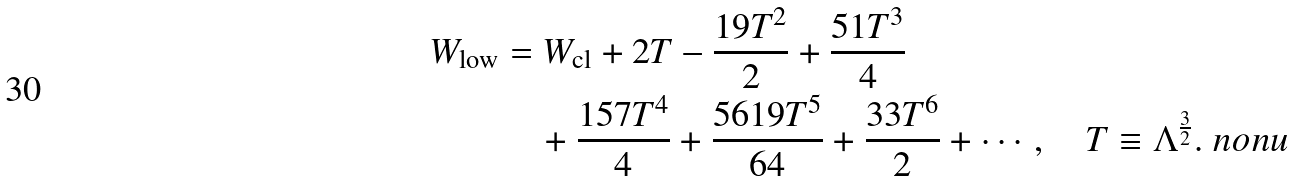Convert formula to latex. <formula><loc_0><loc_0><loc_500><loc_500>W _ { \text {low} } & = W _ { \text {cl} } + 2 T - \frac { 1 9 T ^ { 2 } } { 2 } + \frac { 5 1 T ^ { 3 } } { 4 } \\ & \quad + \frac { 1 5 7 T ^ { 4 } } { 4 } + \frac { 5 6 1 9 T ^ { 5 } } { 6 4 } + \frac { 3 3 T ^ { 6 } } { 2 } + \cdots , \quad T \equiv \Lambda ^ { \frac { 3 } { 2 } } . \ n o n u</formula> 